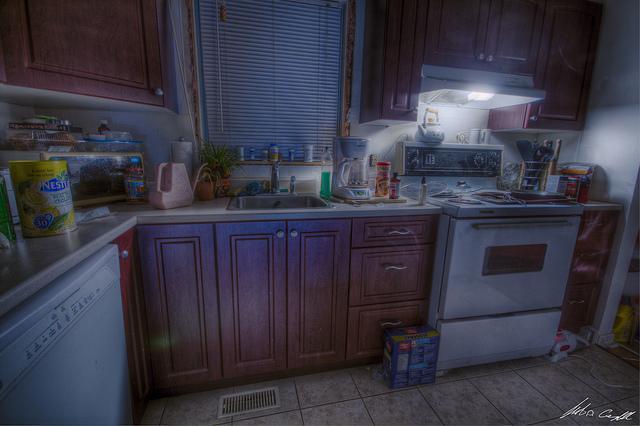How many cows are looking at the camera?
Give a very brief answer. 0. 